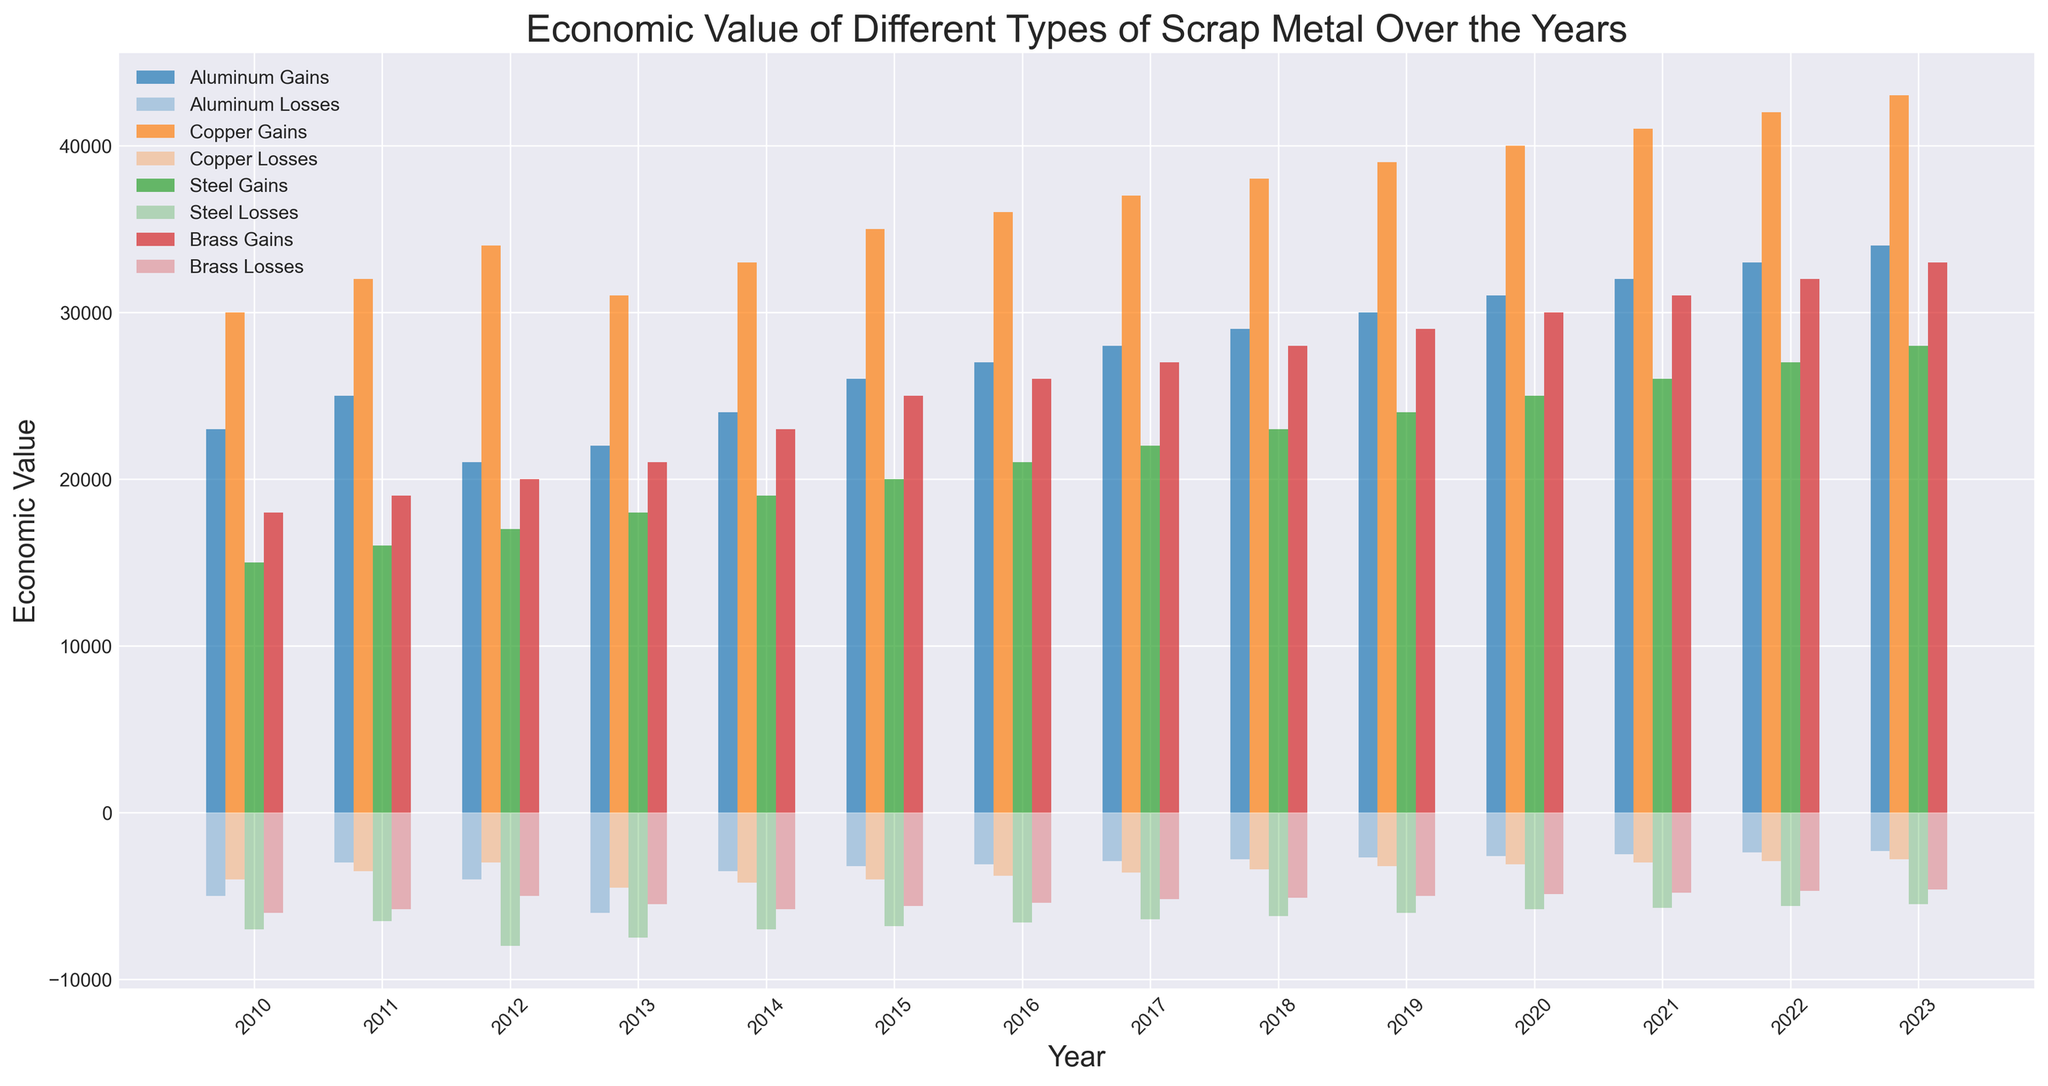Which metal had the highest economic gain in 2023? In the 2023 group on the chart, the bar representing Copper gains is the tallest compared to other metals.
Answer: Copper How do the losses of Aluminum in 2010 compare to those in 2023? Compare the height of the losses of Aluminum bars in 2010 and 2023. The losses bar in 2023 is shorter than the losses bar in 2010.
Answer: Lower in 2023 What is the average gain for Brass over the years 2020, 2021, and 2022? Sum the gains for Brass in 2020 (30000), 2021 (31000), and 2022 (32000), then divide by 3. (30000 + 31000 + 32000) / 3 = 31000.
Answer: 31000 Which year had the smallest loss in Steel? Look for the shortest bar representing Steel losses across all years. The bar for Steel losses in 2020 is the shortest.
Answer: 2020 How much more was Copper's gain compared to Steel's gain in 2016? Subtract Steel gains from Copper gains in 2016. 36000 (Copper gains) - 21000 (Steel gains) = 15000.
Answer: 15000 What is the trend of Aluminum gains from 2010 to 2023? Observe the height changes of Aluminum gain bars from 2010 to 2023. The bars show increasing height from 2010 to 2023.
Answer: Increasing Which type of metal consistently has the highest gains over the years? Compare the highest bars for gains across all metal types and years. Copper gains bars are consistently the highest.
Answer: Copper How do Brass gains in 2012 compare to Brass gains in 2018? Compare the heights of the Brass gains bars for 2012 and 2018. The bar in 2018 is taller than the bar in 2012.
Answer: Higher in 2018 What is the trend in losses for Brass from 2010 to 2023? Observe the changes in height for Brass losses bars from 2010 to 2023. The losses bars show a decreasing trend.
Answer: Decreasing Calculate the total economic gain for Steel over the years 2010, 2011, and 2012. Sum the gains for Steel in 2010 (15000), 2011 (16000), and 2012 (17000). 15000 + 16000 + 17000 = 48000.
Answer: 48000 